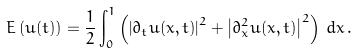Convert formula to latex. <formula><loc_0><loc_0><loc_500><loc_500>E \left ( u ( t ) \right ) = \frac { 1 } { 2 } \int _ { 0 } ^ { 1 } \left ( \left | \partial _ { t } u ( x , t ) \right | ^ { 2 } + \left | \partial _ { x } ^ { 2 } u ( x , t ) \right | ^ { 2 } \right ) \, d x \, .</formula> 